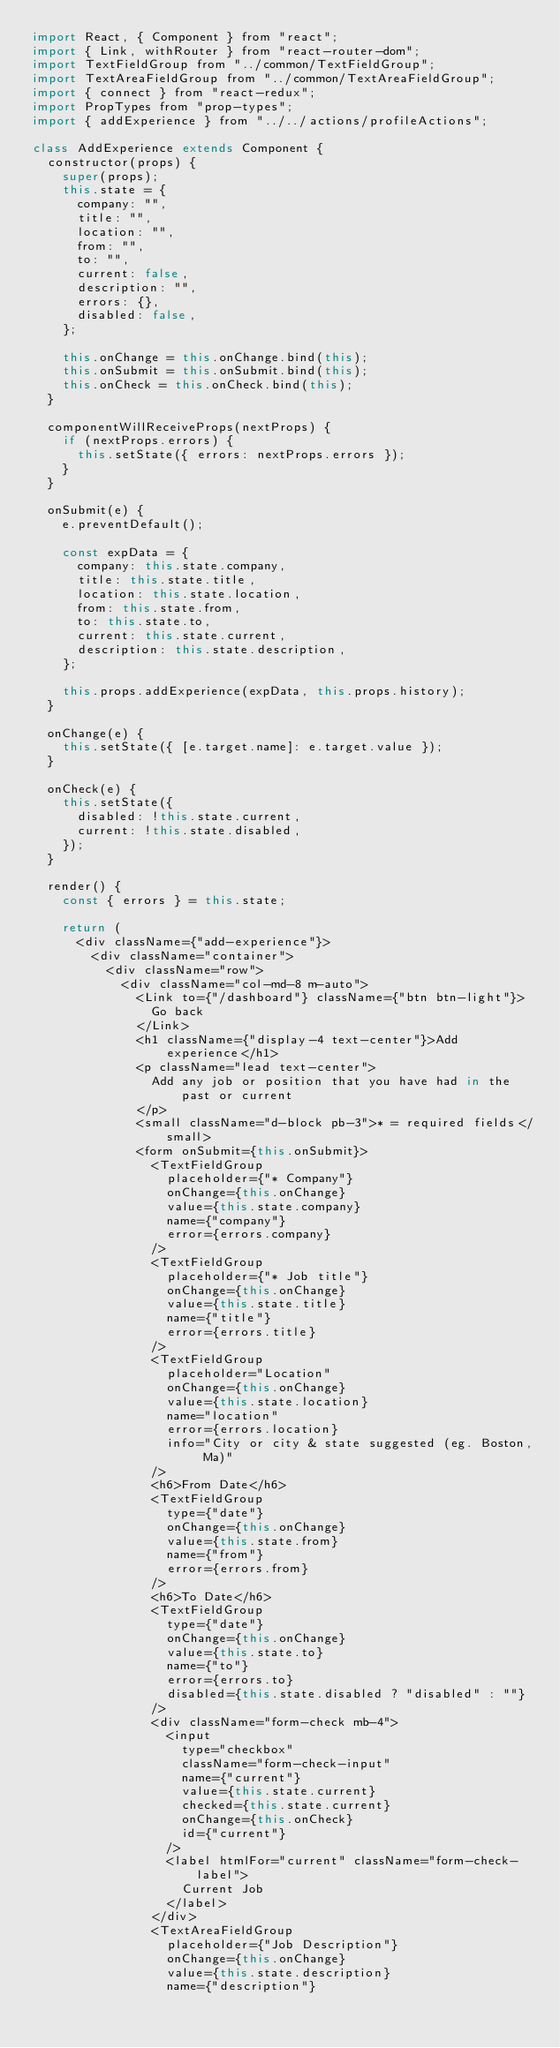<code> <loc_0><loc_0><loc_500><loc_500><_JavaScript_>import React, { Component } from "react";
import { Link, withRouter } from "react-router-dom";
import TextFieldGroup from "../common/TextFieldGroup";
import TextAreaFieldGroup from "../common/TextAreaFieldGroup";
import { connect } from "react-redux";
import PropTypes from "prop-types";
import { addExperience } from "../../actions/profileActions";

class AddExperience extends Component {
  constructor(props) {
    super(props);
    this.state = {
      company: "",
      title: "",
      location: "",
      from: "",
      to: "",
      current: false,
      description: "",
      errors: {},
      disabled: false,
    };

    this.onChange = this.onChange.bind(this);
    this.onSubmit = this.onSubmit.bind(this);
    this.onCheck = this.onCheck.bind(this);
  }

  componentWillReceiveProps(nextProps) {
    if (nextProps.errors) {
      this.setState({ errors: nextProps.errors });
    }
  }

  onSubmit(e) {
    e.preventDefault();

    const expData = {
      company: this.state.company,
      title: this.state.title,
      location: this.state.location,
      from: this.state.from,
      to: this.state.to,
      current: this.state.current,
      description: this.state.description,
    };

    this.props.addExperience(expData, this.props.history);
  }

  onChange(e) {
    this.setState({ [e.target.name]: e.target.value });
  }

  onCheck(e) {
    this.setState({
      disabled: !this.state.current,
      current: !this.state.disabled,
    });
  }

  render() {
    const { errors } = this.state;

    return (
      <div className={"add-experience"}>
        <div className="container">
          <div className="row">
            <div className="col-md-8 m-auto">
              <Link to={"/dashboard"} className={"btn btn-light"}>
                Go back
              </Link>
              <h1 className={"display-4 text-center"}>Add experience</h1>
              <p className="lead text-center">
                Add any job or position that you have had in the past or current
              </p>
              <small className="d-block pb-3">* = required fields</small>
              <form onSubmit={this.onSubmit}>
                <TextFieldGroup
                  placeholder={"* Company"}
                  onChange={this.onChange}
                  value={this.state.company}
                  name={"company"}
                  error={errors.company}
                />
                <TextFieldGroup
                  placeholder={"* Job title"}
                  onChange={this.onChange}
                  value={this.state.title}
                  name={"title"}
                  error={errors.title}
                />
                <TextFieldGroup
                  placeholder="Location"
                  onChange={this.onChange}
                  value={this.state.location}
                  name="location"
                  error={errors.location}
                  info="City or city & state suggested (eg. Boston, Ma)"
                />
                <h6>From Date</h6>
                <TextFieldGroup
                  type={"date"}
                  onChange={this.onChange}
                  value={this.state.from}
                  name={"from"}
                  error={errors.from}
                />
                <h6>To Date</h6>
                <TextFieldGroup
                  type={"date"}
                  onChange={this.onChange}
                  value={this.state.to}
                  name={"to"}
                  error={errors.to}
                  disabled={this.state.disabled ? "disabled" : ""}
                />
                <div className="form-check mb-4">
                  <input
                    type="checkbox"
                    className="form-check-input"
                    name={"current"}
                    value={this.state.current}
                    checked={this.state.current}
                    onChange={this.onCheck}
                    id={"current"}
                  />
                  <label htmlFor="current" className="form-check-label">
                    Current Job
                  </label>
                </div>
                <TextAreaFieldGroup
                  placeholder={"Job Description"}
                  onChange={this.onChange}
                  value={this.state.description}
                  name={"description"}</code> 